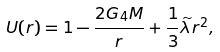Convert formula to latex. <formula><loc_0><loc_0><loc_500><loc_500>U ( r ) = 1 - \frac { 2 G _ { 4 } M } r + \frac { 1 } { 3 } \widetilde { \lambda } r ^ { 2 } ,</formula> 